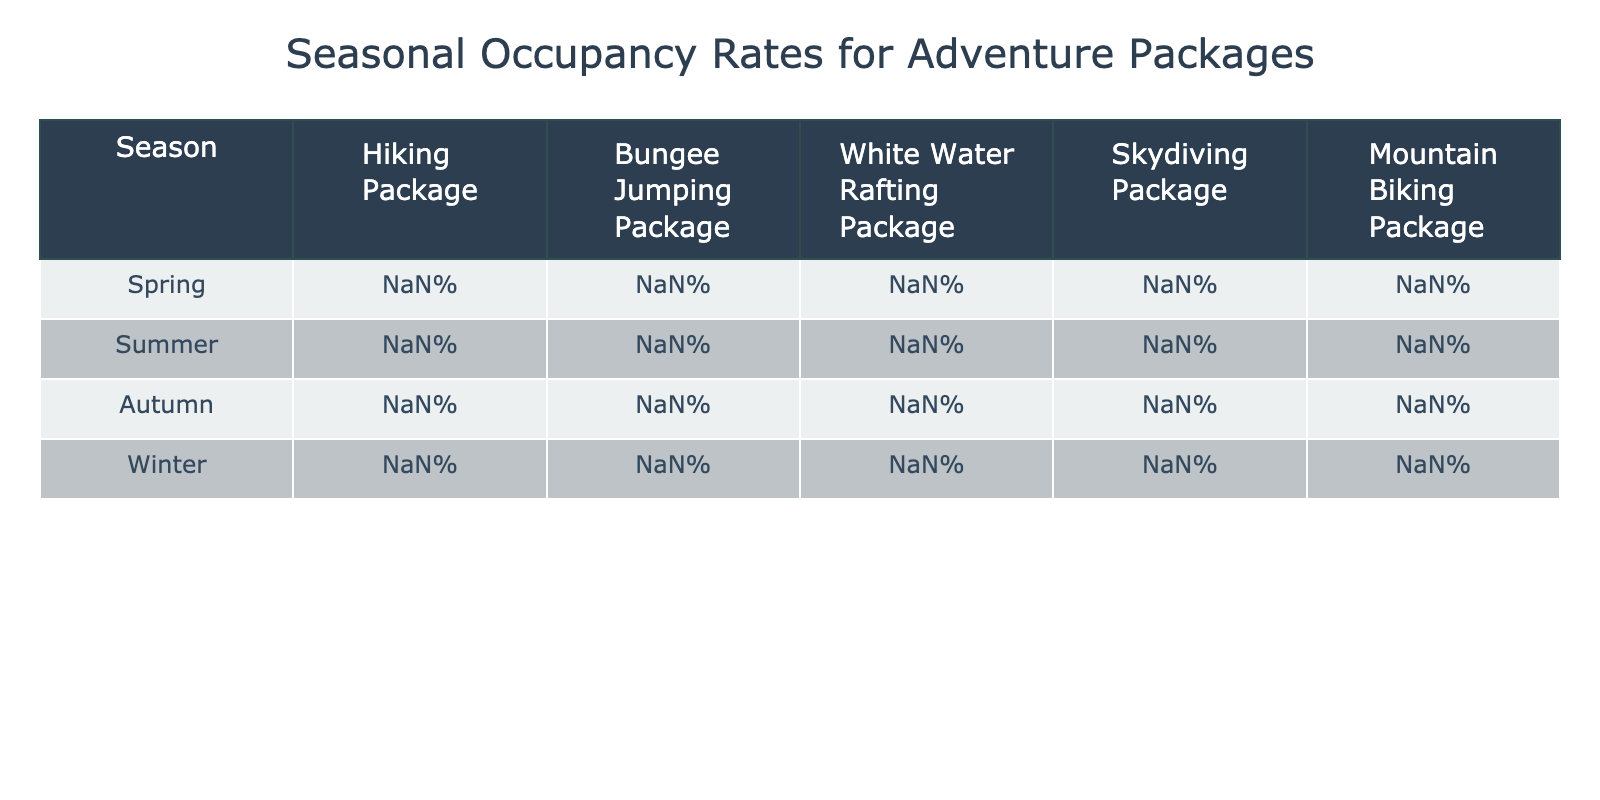What is the highest occupancy rate among all packages in summer? In the summer, the occupancy rates for all packages are: Hiking (89%), Bungee Jumping (83%), White Water Rafting (87%), Skydiving (79%), and Mountain Biking (85%). The highest is Hiking at 89%.
Answer: 89% Which season has the lowest occupancy rate for Skydiving? The occupancy rates for Skydiving across the seasons are: Spring (61%), Summer (79%), Autumn (57%), and Winter (31%). The lowest is Winter at 31%.
Answer: 31% What is the difference in occupancy rates for the Hiking package between summer and winter? The summer occupancy for Hiking is 89% and for winter, it is 43%. The difference is 89% - 43% = 46%.
Answer: 46% In which season is the occupancy rate for Bungee Jumping the highest? The occupancy rates for Bungee Jumping are: Spring (65%), Summer (83%), Autumn (59%), and Winter (37%). The highest is Summer at 83%.
Answer: Summer What is the average occupancy rate for the Mountain Biking package across all seasons? The occupancy rates for Mountain Biking across the seasons are: Spring (69%), Summer (85%), Autumn (71%), and Winter (46%). The average is (69 + 85 + 71 + 46) / 4 = 67.75%.
Answer: 67.75% Is the occupancy rate for White Water Rafting higher in spring than in autumn? The occupancy rates for White Water Rafting are: Spring (58%) and Autumn (52%). Since 58% > 52%, the statement is true.
Answer: Yes What season has the greatest decrease in occupancy rates for the Hiking package from its highest rate? The highest rate for Hiking is in Summer at 89%. In Winter, it drops to 43%, which is a decrease of 46%. The other seasons do not show a greater decline compared to this.
Answer: Winter What is the total occupancy rate for all adventure packages in autumn? The occupancy rates in autumn are: Hiking (68%), Bungee Jumping (59%), White Water Rafting (52%), Skydiving (57%), and Mountain Biking (71%). The total is 68% + 59% + 52% + 57% + 71% = 307%.
Answer: 307% Which package has the best performance in winter compared to the others? In winter, the occupancy rates are: Hiking (43%), Bungee Jumping (37%), White Water Rafting (22%), Skydiving (31%), and Mountain Biking (46%). Mountain Biking has the highest occupancy rate at 46%.
Answer: Mountain Biking 